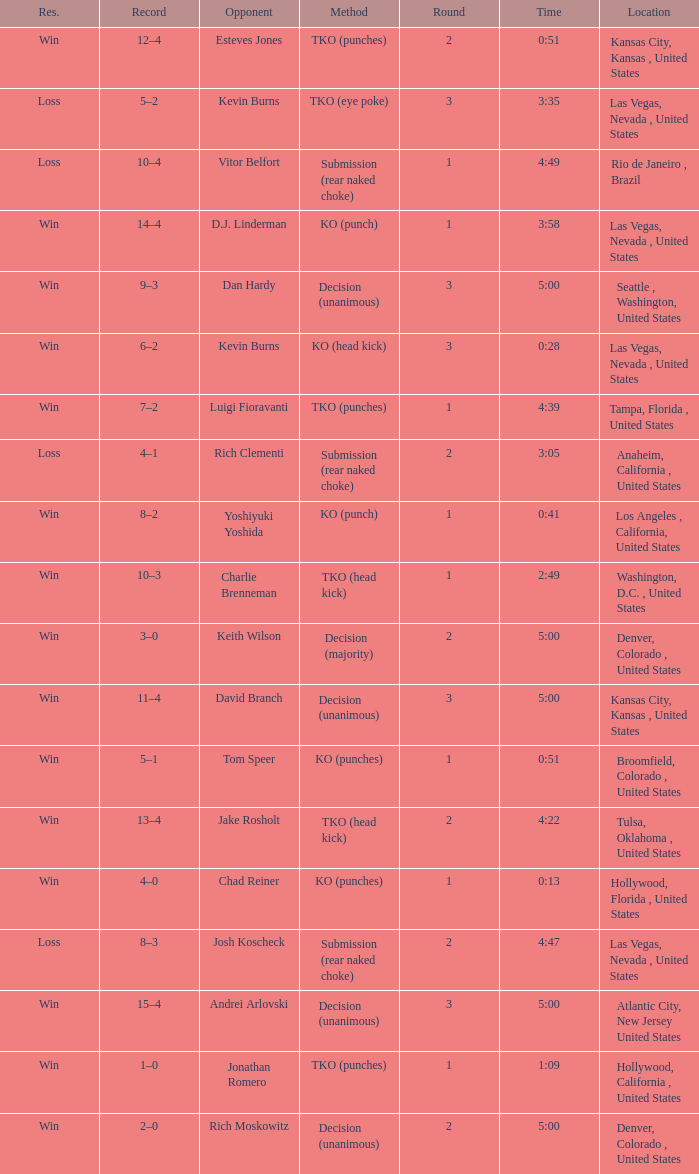Which record has a time of 0:13? 4–0. 